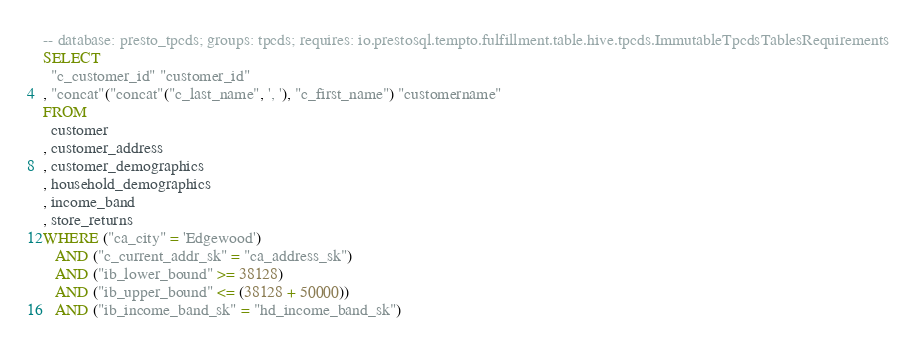<code> <loc_0><loc_0><loc_500><loc_500><_SQL_>-- database: presto_tpcds; groups: tpcds; requires: io.prestosql.tempto.fulfillment.table.hive.tpcds.ImmutableTpcdsTablesRequirements
SELECT
  "c_customer_id" "customer_id"
, "concat"("concat"("c_last_name", ', '), "c_first_name") "customername"
FROM
  customer
, customer_address
, customer_demographics
, household_demographics
, income_band
, store_returns
WHERE ("ca_city" = 'Edgewood')
   AND ("c_current_addr_sk" = "ca_address_sk")
   AND ("ib_lower_bound" >= 38128)
   AND ("ib_upper_bound" <= (38128 + 50000))
   AND ("ib_income_band_sk" = "hd_income_band_sk")</code> 